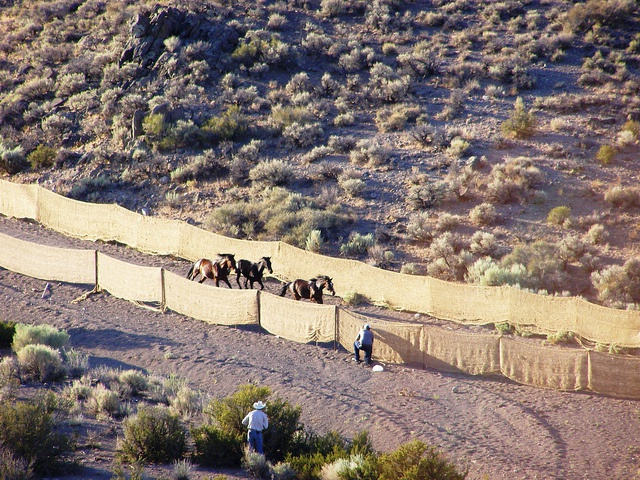Describe the objects in this image and their specific colors. I can see horse in purple, black, darkgray, tan, and gray tones, horse in purple, black, gray, and maroon tones, people in purple, navy, gray, and white tones, horse in purple, black, gray, and darkgray tones, and people in purple, black, white, navy, and gray tones in this image. 